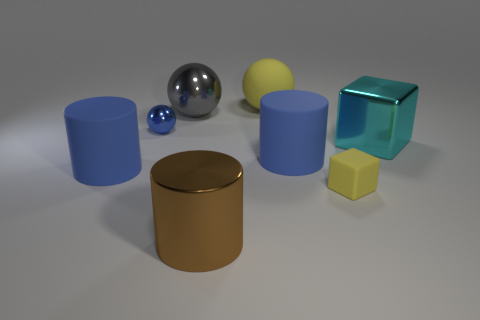What shape is the blue shiny object?
Give a very brief answer. Sphere. Is the small yellow cube made of the same material as the big brown cylinder?
Your answer should be compact. No. Are there an equal number of big brown cylinders that are right of the cyan shiny thing and shiny things that are in front of the blue metallic object?
Offer a very short reply. No. There is a big matte cylinder that is on the right side of the blue matte cylinder that is left of the big yellow matte sphere; is there a blue matte cylinder in front of it?
Make the answer very short. Yes. Do the brown cylinder and the cyan object have the same size?
Your answer should be very brief. Yes. What color is the big rubber object behind the block that is behind the tiny yellow matte cube that is to the left of the cyan shiny thing?
Your response must be concise. Yellow. How many large rubber objects have the same color as the tiny ball?
Your response must be concise. 2. How many large things are either rubber things or shiny cubes?
Your response must be concise. 4. Are there any big shiny objects that have the same shape as the small rubber object?
Provide a short and direct response. Yes. Is the tiny yellow object the same shape as the big cyan metallic object?
Your response must be concise. Yes. 